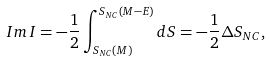<formula> <loc_0><loc_0><loc_500><loc_500>I m \, I = - \frac { 1 } { 2 } \int _ { S _ { N C } ( M ) } ^ { S _ { N C } ( M - E ) } d S = - \frac { 1 } { 2 } \Delta S _ { N C } ,</formula> 